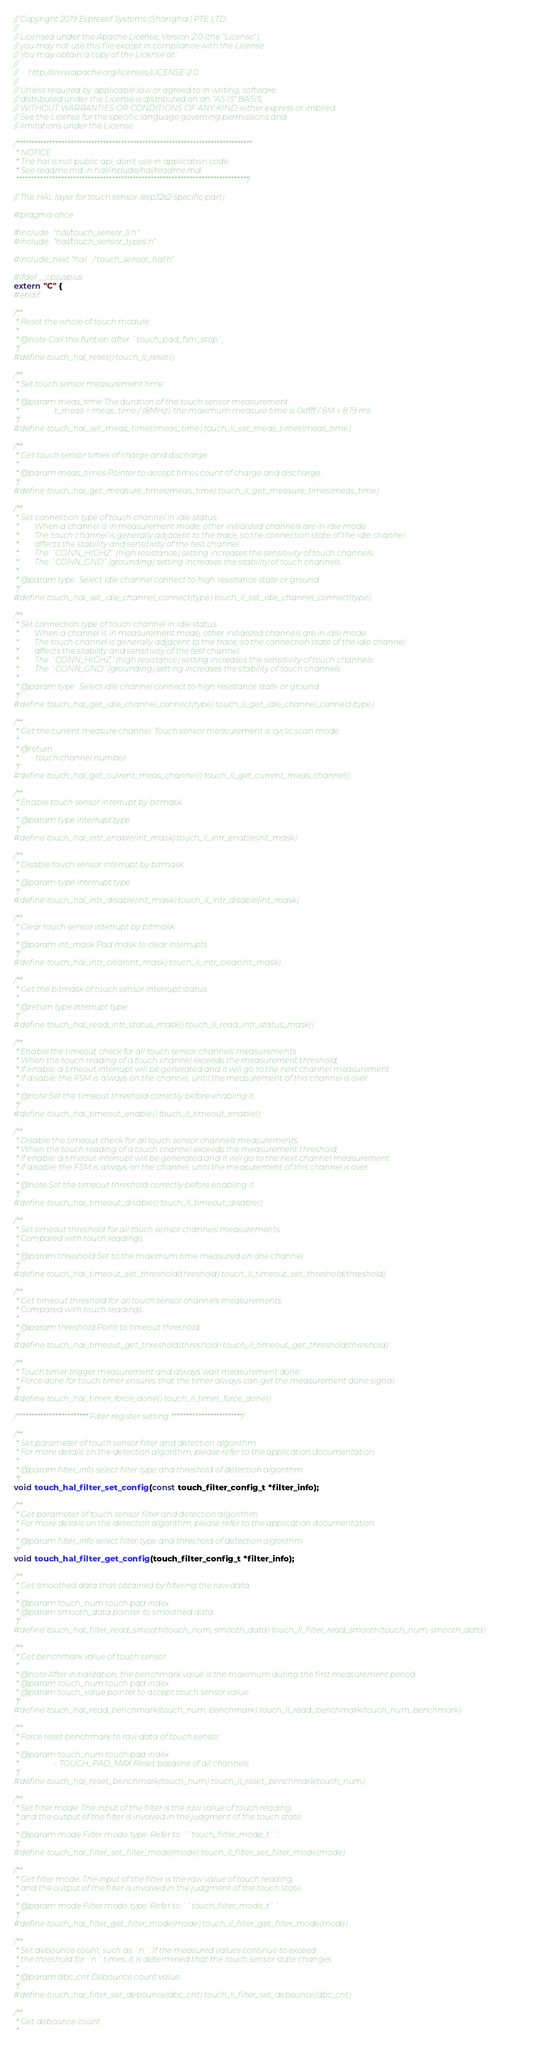Convert code to text. <code><loc_0><loc_0><loc_500><loc_500><_C_>// Copyright 2019 Espressif Systems (Shanghai) PTE LTD
//
// Licensed under the Apache License, Version 2.0 (the "License");
// you may not use this file except in compliance with the License.
// You may obtain a copy of the License at
//
//     http://www.apache.org/licenses/LICENSE-2.0
//
// Unless required by applicable law or agreed to in writing, software
// distributed under the License is distributed on an "AS IS" BASIS,
// WITHOUT WARRANTIES OR CONDITIONS OF ANY KIND, either express or implied.
// See the License for the specific language governing permissions and
// limitations under the License.

/*******************************************************************************
 * NOTICE
 * The hal is not public api, don't use in application code.
 * See readme.md in hal/include/hal/readme.md
 ******************************************************************************/

// The HAL layer for touch sensor (esp32s2 specific part)

#pragma once

#include "hal/touch_sensor_ll.h"
#include "hal/touch_sensor_types.h"

#include_next "hal/touch_sensor_hal.h"

#ifdef __cplusplus
extern "C" {
#endif

/**
 * Reset the whole of touch module.
 *
 * @note Call this funtion after `touch_pad_fsm_stop`,
 */
#define touch_hal_reset() touch_ll_reset()

/**
 * Set touch sensor measurement time.
 *
 * @param meas_time The duration of the touch sensor measurement.
 *                  t_meas = meas_time / (8MHz), the maximum measure time is 0xffff / 8M = 8.19 ms.
 */
#define touch_hal_set_meas_times(meas_time) touch_ll_set_meas_times(meas_time)

/**
 * Get touch sensor times of charge and discharge.
 *
 * @param meas_times Pointer to accept times count of charge and discharge.
 */
#define touch_hal_get_measure_times(meas_time) touch_ll_get_measure_times(meas_time)

/**
 * Set connection type of touch channel in idle status.
 *        When a channel is in measurement mode, other initialized channels are in idle mode.
 *        The touch channel is generally adjacent to the trace, so the connection state of the idle channel
 *        affects the stability and sensitivity of the test channel.
 *        The `CONN_HIGHZ`(high resistance) setting increases the sensitivity of touch channels.
 *        The `CONN_GND`(grounding) setting increases the stability of touch channels.
 *
 * @param type  Select idle channel connect to high resistance state or ground.
 */
#define touch_hal_set_idle_channel_connect(type) touch_ll_set_idle_channel_connect(type)

/**
 * Set connection type of touch channel in idle status.
 *        When a channel is in measurement mode, other initialized channels are in idle mode.
 *        The touch channel is generally adjacent to the trace, so the connection state of the idle channel
 *        affects the stability and sensitivity of the test channel.
 *        The `CONN_HIGHZ`(high resistance) setting increases the sensitivity of touch channels.
 *        The `CONN_GND`(grounding) setting increases the stability of touch channels.
 *
 * @param type  Select idle channel connect to high resistance state or ground.
 */
#define touch_hal_get_idle_channel_connect(type) touch_ll_get_idle_channel_connect(type)

/**
 * Get the current measure channel. Touch sensor measurement is cyclic scan mode.
 *
 * @return
 *      - touch channel number
 */
#define touch_hal_get_current_meas_channel() touch_ll_get_current_meas_channel()

/**
 * Enable touch sensor interrupt by bitmask.
 *
 * @param type interrupt type
 */
#define touch_hal_intr_enable(int_mask) touch_ll_intr_enable(int_mask)

/**
 * Disable touch sensor interrupt by bitmask.
 *
 * @param type interrupt type
 */
#define touch_hal_intr_disable(int_mask) touch_ll_intr_disable(int_mask)

/**
 * Clear touch sensor interrupt by bitmask.
 *
 * @param int_mask Pad mask to clear interrupts
 */
#define touch_hal_intr_clear(int_mask) touch_ll_intr_clear(int_mask)

/**
 * Get the bitmask of touch sensor interrupt status.
 *
 * @return type interrupt type
 */
#define touch_hal_read_intr_status_mask() touch_ll_read_intr_status_mask()

/**
 * Enable the timeout check for all touch sensor channels measurements.
 * When the touch reading of a touch channel exceeds the measurement threshold,
 * If enable: a timeout interrupt will be generated and it will go to the next channel measurement.
 * If disable: the FSM is always on the channel, until the measurement of this channel is over.
 *
 * @note Set the timeout threshold correctly before enabling it.
 */
#define touch_hal_timeout_enable() touch_ll_timeout_enable()

/**
 * Disable the timeout check for all touch sensor channels measurements.
 * When the touch reading of a touch channel exceeds the measurement threshold,
 * If enable: a timeout interrupt will be generated and it will go to the next channel measurement.
 * If disable: the FSM is always on the channel, until the measurement of this channel is over.
 *
 * @note Set the timeout threshold correctly before enabling it.
 */
#define touch_hal_timeout_disable() touch_ll_timeout_disable()

/**
 * Set timeout threshold for all touch sensor channels measurements.
 * Compared with touch readings.
 *
 * @param threshold Set to the maximum time measured on one channel.
 */
#define touch_hal_timeout_set_threshold(threshold) touch_ll_timeout_set_threshold(threshold)

/**
 * Get timeout threshold for all touch sensor channels measurements.
 * Compared with touch readings.
 *
 * @param threshold Point to timeout threshold.
 */
#define touch_hal_timeout_get_threshold(threshold) touch_ll_timeout_get_threshold(threshold)

/**
 * Touch timer trigger measurement and always wait measurement done.
 * Force done for touch timer ensures that the timer always can get the measurement done signal.
 */
#define touch_hal_timer_force_done() touch_ll_timer_force_done()

/************************ Filter register setting ************************/

/**
 * Set parameter of touch sensor filter and detection algorithm.
 * For more details on the detection algorithm, please refer to the application documentation.
 *
 * @param filter_info select filter type and threshold of detection algorithm
 */
void touch_hal_filter_set_config(const touch_filter_config_t *filter_info);

/**
 * Get parameter of touch sensor filter and detection algorithm.
 * For more details on the detection algorithm, please refer to the application documentation.
 *
 * @param filter_info select filter type and threshold of detection algorithm
 */
void touch_hal_filter_get_config(touch_filter_config_t *filter_info);

/**
 * Get smoothed data that obtained by filtering the raw data.
 *
 * @param touch_num touch pad index
 * @param smooth_data pointer to smoothed data
 */
#define touch_hal_filter_read_smooth(touch_num, smooth_data) touch_ll_filter_read_smooth(touch_num, smooth_data)

/**
 * Get benchmark value of touch sensor.
 *
 * @note After initialization, the benchmark value is the maximum during the first measurement period.
 * @param touch_num touch pad index
 * @param touch_value pointer to accept touch sensor value
 */
#define touch_hal_read_benchmark(touch_num, benchmark) touch_ll_read_benchmark(touch_num, benchmark)

/**
 * Force reset benchmark to raw data of touch sensor.
 *
 * @param touch_num touch pad index
 *                  - TOUCH_PAD_MAX Reset basaline of all channels.
 */
#define touch_hal_reset_benchmark(touch_num) touch_ll_reset_benchmark(touch_num)

/**
 * Set filter mode. The input of the filter is the raw value of touch reading,
 * and the output of the filter is involved in the judgment of the touch state.
 *
 * @param mode Filter mode type. Refer to ``touch_filter_mode_t``.
 */
#define touch_hal_filter_set_filter_mode(mode) touch_ll_filter_set_filter_mode(mode)

/**
 * Get filter mode. The input of the filter is the raw value of touch reading,
 * and the output of the filter is involved in the judgment of the touch state.
 *
 * @param mode Filter mode type. Refer to ``touch_filter_mode_t``.
 */
#define touch_hal_filter_get_filter_mode(mode) touch_ll_filter_get_filter_mode(mode)

/**
 * Set debounce count, such as `n`. If the measured values continue to exceed
 * the threshold for `n` times, it is determined that the touch sensor state changes.
 *
 * @param dbc_cnt Debounce count value.
 */
#define touch_hal_filter_set_debounce(dbc_cnt) touch_ll_filter_set_debounce(dbc_cnt)

/**
 * Get debounce count.
 *</code> 